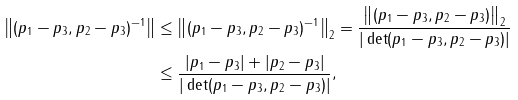<formula> <loc_0><loc_0><loc_500><loc_500>\left \| ( p _ { 1 } - p _ { 3 } , p _ { 2 } - p _ { 3 } ) ^ { - 1 } \right \| & \leq \left \| ( p _ { 1 } - p _ { 3 } , p _ { 2 } - p _ { 3 } ) ^ { - 1 } \right \| _ { 2 } = \frac { \left \| ( p _ { 1 } - p _ { 3 } , p _ { 2 } - p _ { 3 } ) \right \| _ { 2 } } { | \det ( p _ { 1 } - p _ { 3 } , p _ { 2 } - p _ { 3 } ) | } \\ & \leq \frac { | p _ { 1 } - p _ { 3 } | + | p _ { 2 } - p _ { 3 } | } { | \det ( p _ { 1 } - p _ { 3 } , p _ { 2 } - p _ { 3 } ) | } ,</formula> 